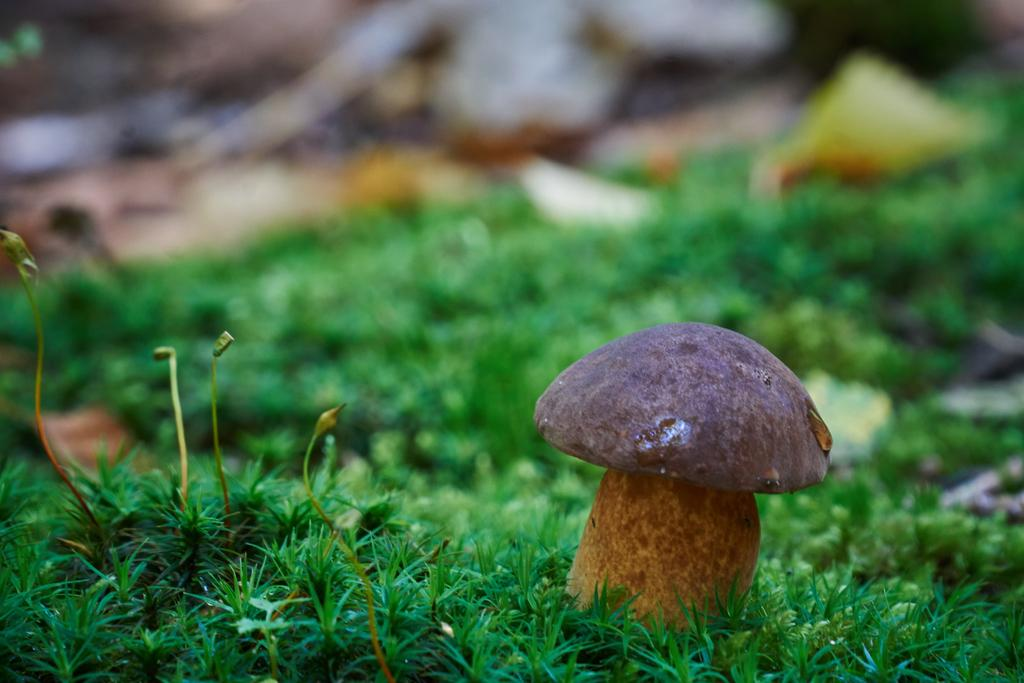What type of plant can be seen in the grass in the image? There is a mushroom in the grass in the image. Can you describe the background of the image? The background of the image is blurry. How many pails of water are being carried by the cows in the image? There are no cows or pails of water present in the image; it only features a mushroom in the grass with a blurry background. 